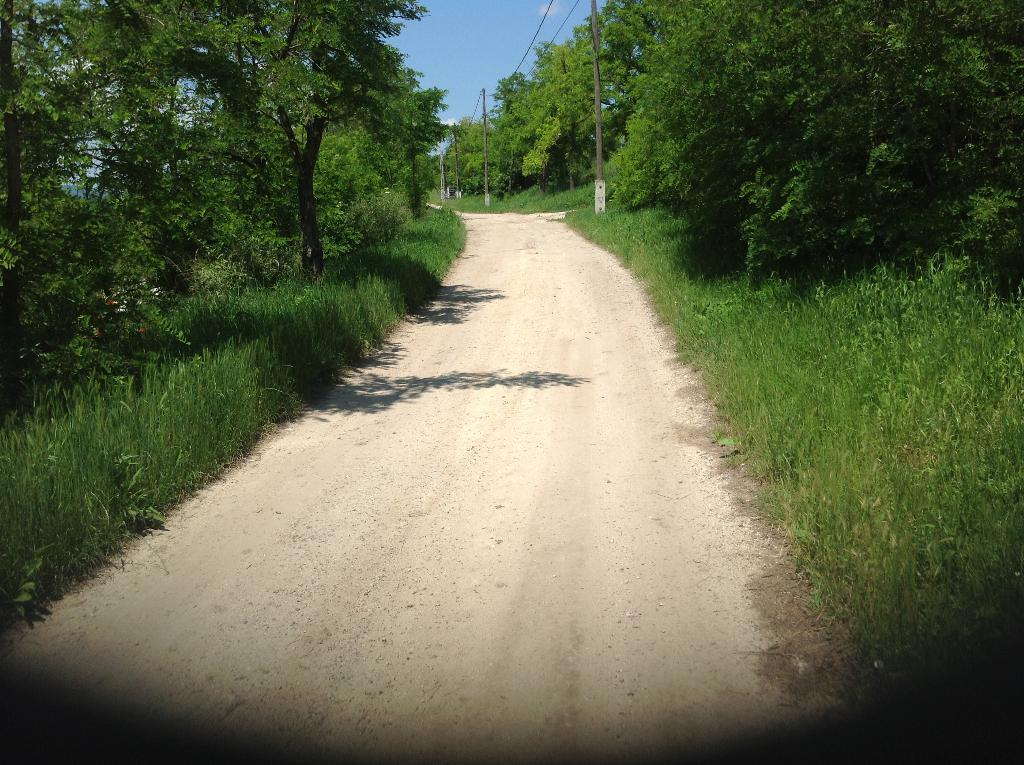What type of surface can be seen in the image? There is a path and ground with grass visible in the image. What other natural elements are present in the image? There are plants and trees in the image. What man-made structures can be seen in the image? Poles and wires are visible in the image. What is visible in the sky in the image? The sky is visible in the image, with clouds present. How many boys are drawing with chalk on the path in the image? There are no boys or chalk present in the image. What is the limit of the path in the image? The path does not have a visible limit in the image. 